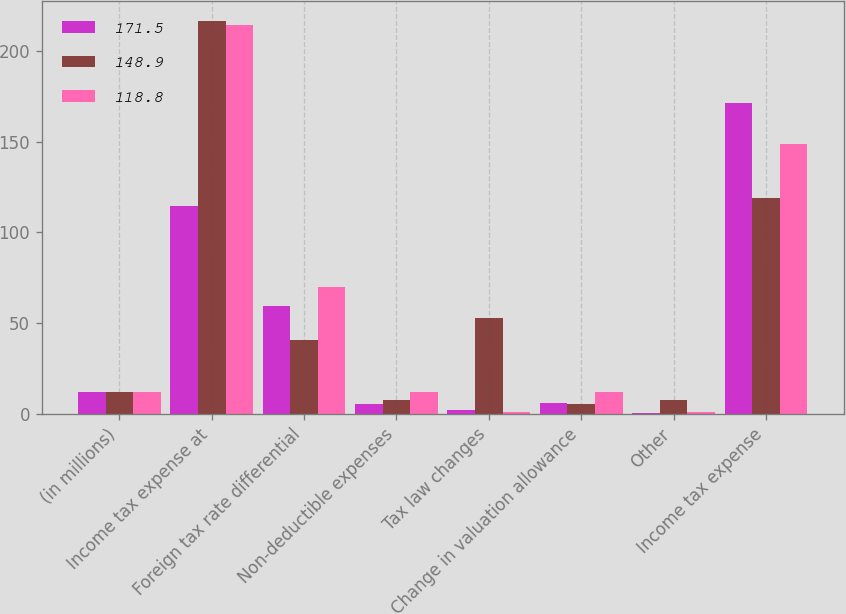<chart> <loc_0><loc_0><loc_500><loc_500><stacked_bar_chart><ecel><fcel>(in millions)<fcel>Income tax expense at<fcel>Foreign tax rate differential<fcel>Non-deductible expenses<fcel>Tax law changes<fcel>Change in valuation allowance<fcel>Other<fcel>Income tax expense<nl><fcel>171.5<fcel>12.1<fcel>114.8<fcel>59.5<fcel>5.6<fcel>2.3<fcel>5.9<fcel>0.2<fcel>171.5<nl><fcel>148.9<fcel>12.1<fcel>216.9<fcel>40.8<fcel>7.7<fcel>52.9<fcel>5.3<fcel>7.7<fcel>118.8<nl><fcel>118.8<fcel>12.1<fcel>214.7<fcel>69.9<fcel>12.1<fcel>0.7<fcel>12<fcel>0.9<fcel>148.9<nl></chart> 